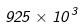<formula> <loc_0><loc_0><loc_500><loc_500>9 2 5 \times 1 0 ^ { 3 }</formula> 